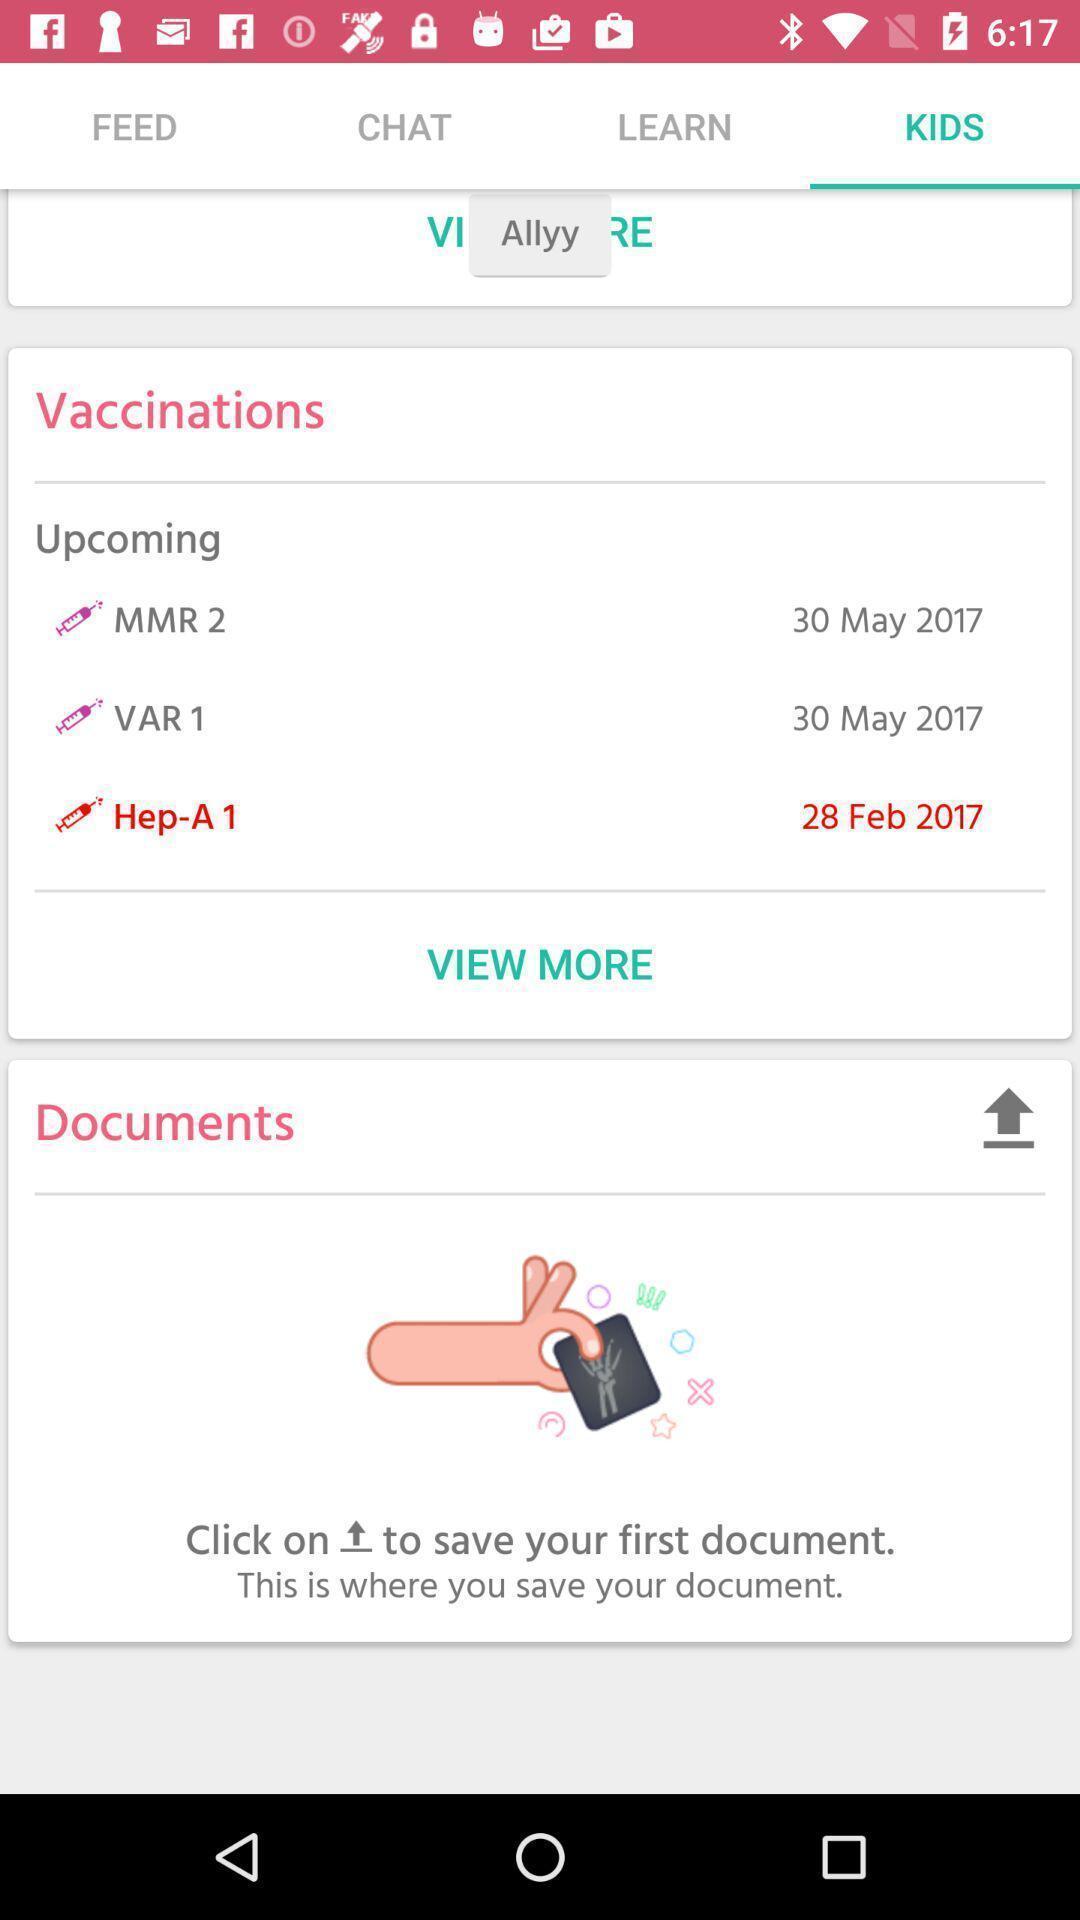Give me a summary of this screen capture. Screen shows vaccination details in a health app. 